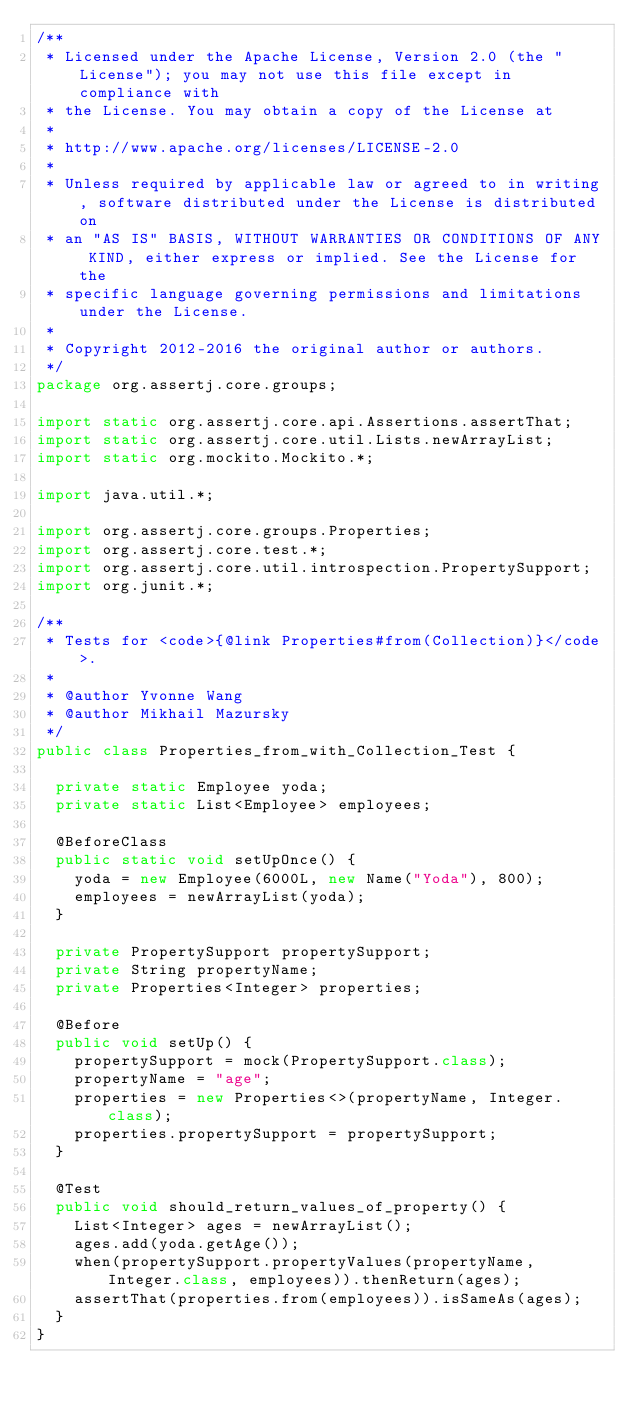<code> <loc_0><loc_0><loc_500><loc_500><_Java_>/**
 * Licensed under the Apache License, Version 2.0 (the "License"); you may not use this file except in compliance with
 * the License. You may obtain a copy of the License at
 *
 * http://www.apache.org/licenses/LICENSE-2.0
 *
 * Unless required by applicable law or agreed to in writing, software distributed under the License is distributed on
 * an "AS IS" BASIS, WITHOUT WARRANTIES OR CONDITIONS OF ANY KIND, either express or implied. See the License for the
 * specific language governing permissions and limitations under the License.
 *
 * Copyright 2012-2016 the original author or authors.
 */
package org.assertj.core.groups;

import static org.assertj.core.api.Assertions.assertThat;
import static org.assertj.core.util.Lists.newArrayList;
import static org.mockito.Mockito.*;

import java.util.*;

import org.assertj.core.groups.Properties;
import org.assertj.core.test.*;
import org.assertj.core.util.introspection.PropertySupport;
import org.junit.*;

/**
 * Tests for <code>{@link Properties#from(Collection)}</code>.
 * 
 * @author Yvonne Wang
 * @author Mikhail Mazursky
 */
public class Properties_from_with_Collection_Test {

  private static Employee yoda;
  private static List<Employee> employees;

  @BeforeClass
  public static void setUpOnce() {
    yoda = new Employee(6000L, new Name("Yoda"), 800);
    employees = newArrayList(yoda);
  }

  private PropertySupport propertySupport;
  private String propertyName;
  private Properties<Integer> properties;

  @Before
  public void setUp() {
    propertySupport = mock(PropertySupport.class);
    propertyName = "age";
    properties = new Properties<>(propertyName, Integer.class);
    properties.propertySupport = propertySupport;
  }

  @Test
  public void should_return_values_of_property() {
    List<Integer> ages = newArrayList();
    ages.add(yoda.getAge());
    when(propertySupport.propertyValues(propertyName, Integer.class, employees)).thenReturn(ages);
    assertThat(properties.from(employees)).isSameAs(ages);
  }
}
</code> 